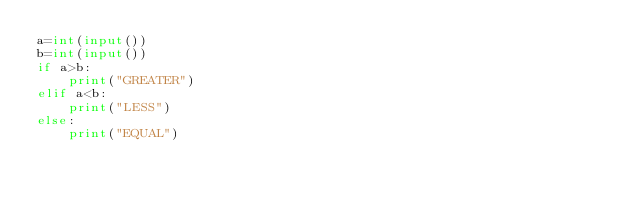Convert code to text. <code><loc_0><loc_0><loc_500><loc_500><_Python_>a=int(input())
b=int(input())
if a>b:
    print("GREATER")
elif a<b:
    print("LESS")
else:
    print("EQUAL")</code> 